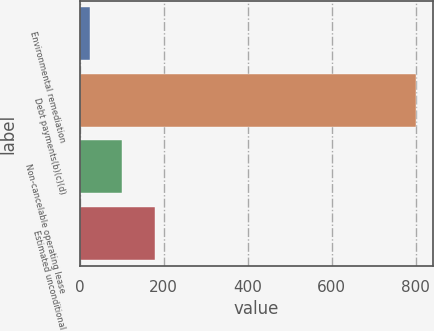Convert chart. <chart><loc_0><loc_0><loc_500><loc_500><bar_chart><fcel>Environmental remediation<fcel>Debt payments(b)(c)(d)<fcel>Non-cancelable operating lease<fcel>Estimated unconditional<nl><fcel>24<fcel>801<fcel>101.7<fcel>179.4<nl></chart> 